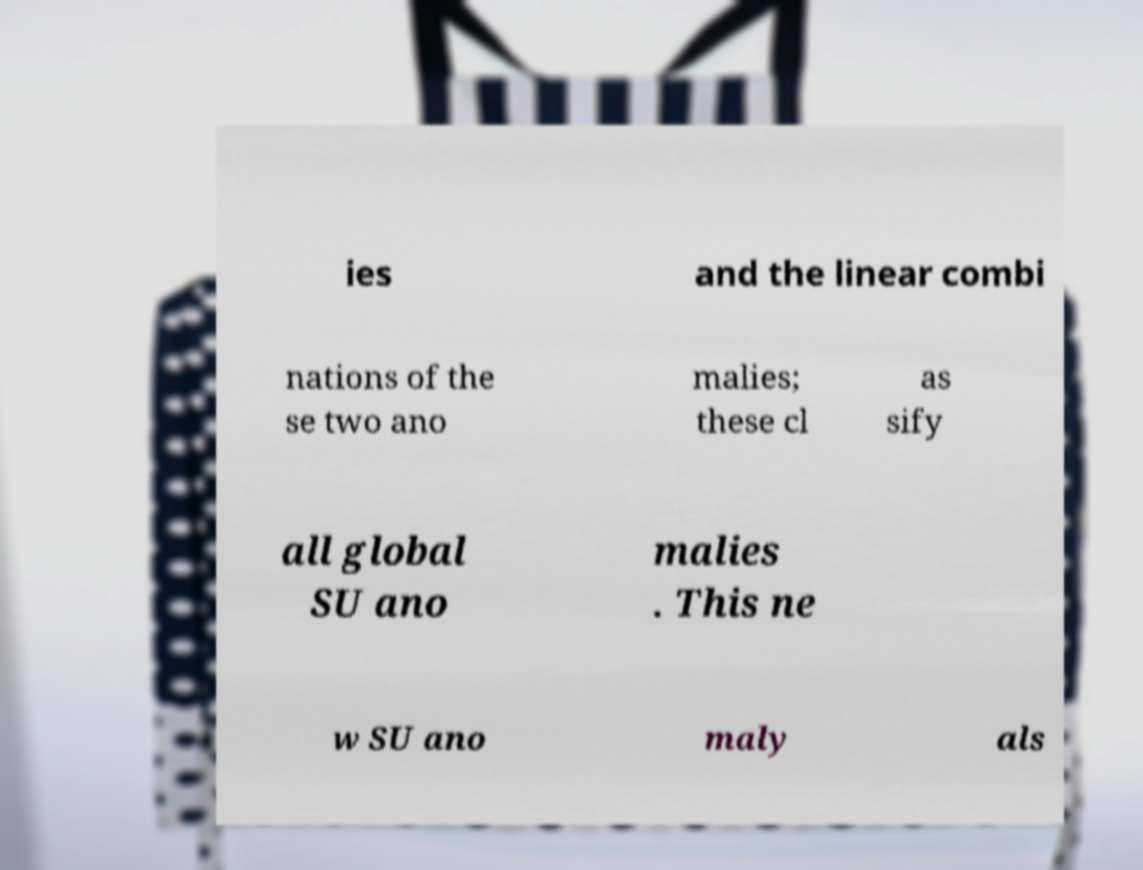Could you extract and type out the text from this image? ies and the linear combi nations of the se two ano malies; these cl as sify all global SU ano malies . This ne w SU ano maly als 